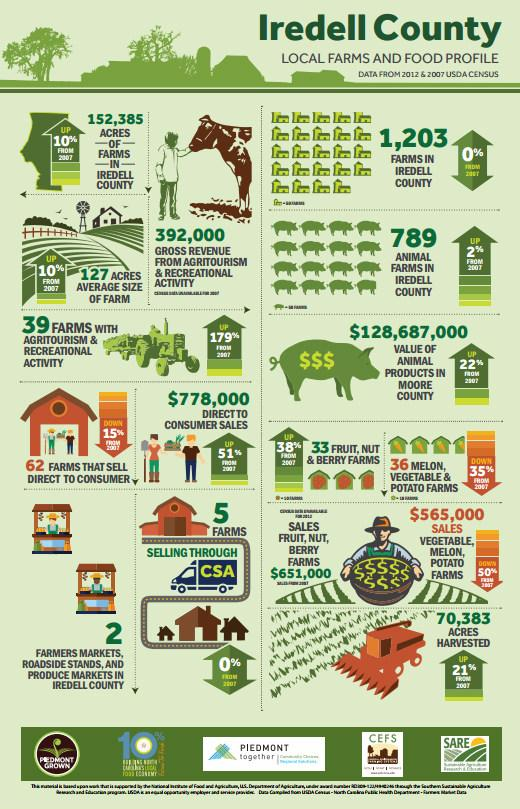Outline some significant characteristics in this image. Iredell county farms that sold through CSA and did not experience any changes from 2007 to 2012 are the focus of the study. The number of melon, vegetable, and potato farms decreased from 2007 to 2012. 